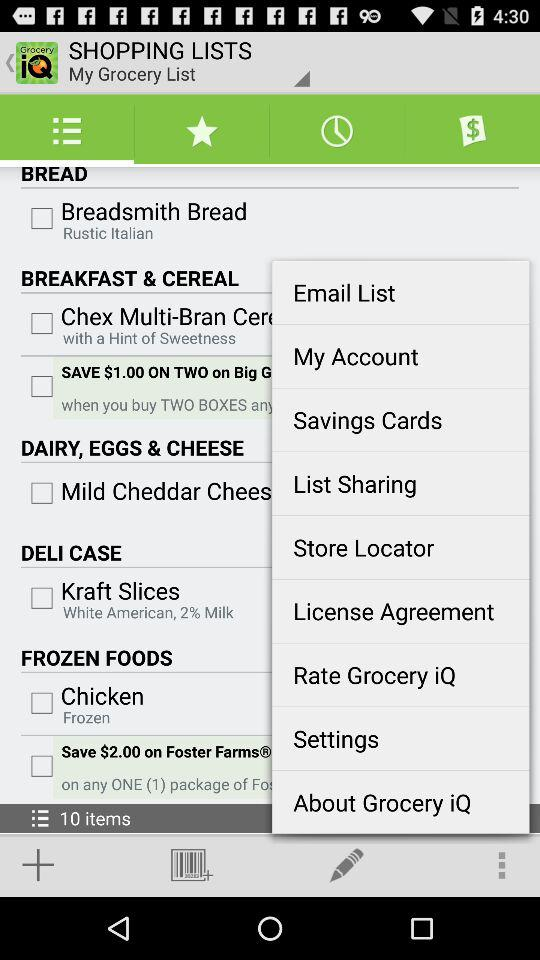What kind of chicken is there? The type of chicken is "Frozen". 